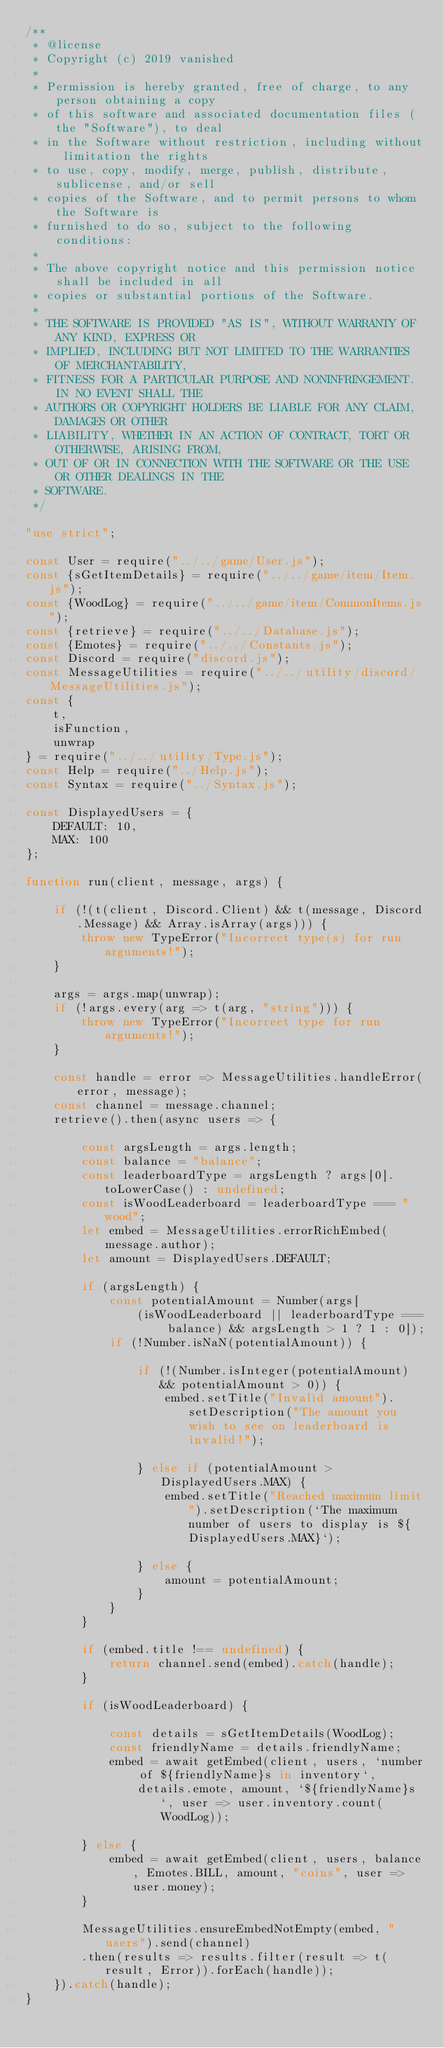Convert code to text. <code><loc_0><loc_0><loc_500><loc_500><_JavaScript_>/**
 * @license
 * Copyright (c) 2019 vanished
 * 
 * Permission is hereby granted, free of charge, to any person obtaining a copy
 * of this software and associated documentation files (the "Software"), to deal
 * in the Software without restriction, including without limitation the rights
 * to use, copy, modify, merge, publish, distribute, sublicense, and/or sell
 * copies of the Software, and to permit persons to whom the Software is
 * furnished to do so, subject to the following conditions:
 * 
 * The above copyright notice and this permission notice shall be included in all
 * copies or substantial portions of the Software.
 * 
 * THE SOFTWARE IS PROVIDED "AS IS", WITHOUT WARRANTY OF ANY KIND, EXPRESS OR
 * IMPLIED, INCLUDING BUT NOT LIMITED TO THE WARRANTIES OF MERCHANTABILITY,
 * FITNESS FOR A PARTICULAR PURPOSE AND NONINFRINGEMENT. IN NO EVENT SHALL THE
 * AUTHORS OR COPYRIGHT HOLDERS BE LIABLE FOR ANY CLAIM, DAMAGES OR OTHER
 * LIABILITY, WHETHER IN AN ACTION OF CONTRACT, TORT OR OTHERWISE, ARISING FROM,
 * OUT OF OR IN CONNECTION WITH THE SOFTWARE OR THE USE OR OTHER DEALINGS IN THE
 * SOFTWARE.
 */

"use strict";

const User = require("../../game/User.js");
const {sGetItemDetails} = require("../../game/item/Item.js");
const {WoodLog} = require("../../game/item/CommonItems.js");
const {retrieve} = require("../../Database.js");
const {Emotes} = require("../../Constants.js");
const Discord = require("discord.js");
const MessageUtilities = require("../../utility/discord/MessageUtilities.js");
const {
    t,
    isFunction,
    unwrap
} = require("../../utility/Type.js");
const Help = require("../Help.js");
const Syntax = require("../Syntax.js");

const DisplayedUsers = {
    DEFAULT: 10,
    MAX: 100
};

function run(client, message, args) {

    if (!(t(client, Discord.Client) && t(message, Discord.Message) && Array.isArray(args))) {
        throw new TypeError("Incorrect type(s) for run arguments!");
    }

    args = args.map(unwrap);
    if (!args.every(arg => t(arg, "string"))) {
        throw new TypeError("Incorrect type for run arguments!");
    }

    const handle = error => MessageUtilities.handleError(error, message);
    const channel = message.channel;
    retrieve().then(async users => {

        const argsLength = args.length;
        const balance = "balance";
        const leaderboardType = argsLength ? args[0].toLowerCase() : undefined;
        const isWoodLeaderboard = leaderboardType === "wood";
        let embed = MessageUtilities.errorRichEmbed(message.author);
        let amount = DisplayedUsers.DEFAULT;

        if (argsLength) {
            const potentialAmount = Number(args[
                (isWoodLeaderboard || leaderboardType === balance) && argsLength > 1 ? 1 : 0]);
            if (!Number.isNaN(potentialAmount)) {

                if (!(Number.isInteger(potentialAmount) && potentialAmount > 0)) {
                    embed.setTitle("Invalid amount").setDescription("The amount you wish to see on leaderboard is invalid!");

                } else if (potentialAmount > DisplayedUsers.MAX) {
                    embed.setTitle("Reached maximum limit").setDescription(`The maximum number of users to display is ${DisplayedUsers.MAX}`);

                } else {
                    amount = potentialAmount;
                }
            }
        }

        if (embed.title !== undefined) {
            return channel.send(embed).catch(handle);
        }

        if (isWoodLeaderboard) {

            const details = sGetItemDetails(WoodLog);
            const friendlyName = details.friendlyName;
            embed = await getEmbed(client, users, `number of ${friendlyName}s in inventory`,
                details.emote, amount, `${friendlyName}s`, user => user.inventory.count(WoodLog));

        } else {
            embed = await getEmbed(client, users, balance, Emotes.BILL, amount, "coins", user => user.money);
        }

        MessageUtilities.ensureEmbedNotEmpty(embed, "users").send(channel)
        .then(results => results.filter(result => t(result, Error)).forEach(handle));
    }).catch(handle);
}
</code> 